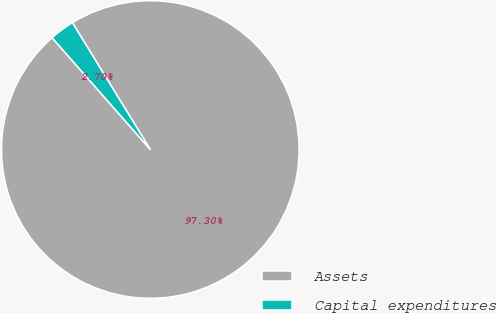Convert chart to OTSL. <chart><loc_0><loc_0><loc_500><loc_500><pie_chart><fcel>Assets<fcel>Capital expenditures<nl><fcel>97.3%<fcel>2.7%<nl></chart> 